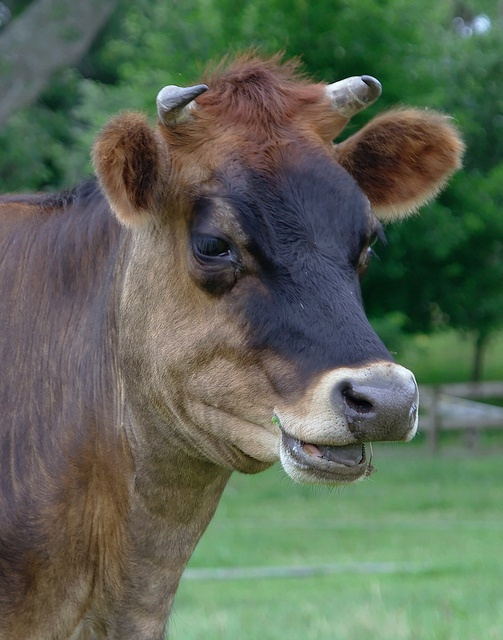Describe the objects in this image and their specific colors. I can see a cow in black and gray tones in this image. 